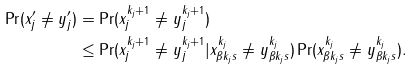<formula> <loc_0><loc_0><loc_500><loc_500>\Pr ( x _ { j } ^ { \prime } \neq y _ { j } ^ { \prime } ) & = \Pr ( x _ { j } ^ { k _ { j } + 1 } \neq y _ { j } ^ { k _ { j } + 1 } ) \\ & \leq \Pr ( x _ { j } ^ { k _ { j } + 1 } \neq y _ { j } ^ { k _ { j } + 1 } | x _ { \beta k _ { j } s } ^ { k _ { j } } \neq y _ { \beta k _ { j } s } ^ { k _ { j } } ) \Pr ( x _ { \beta k _ { j } s } ^ { k _ { j } } \neq y _ { \beta k _ { j } s } ^ { k _ { j } } ) .</formula> 